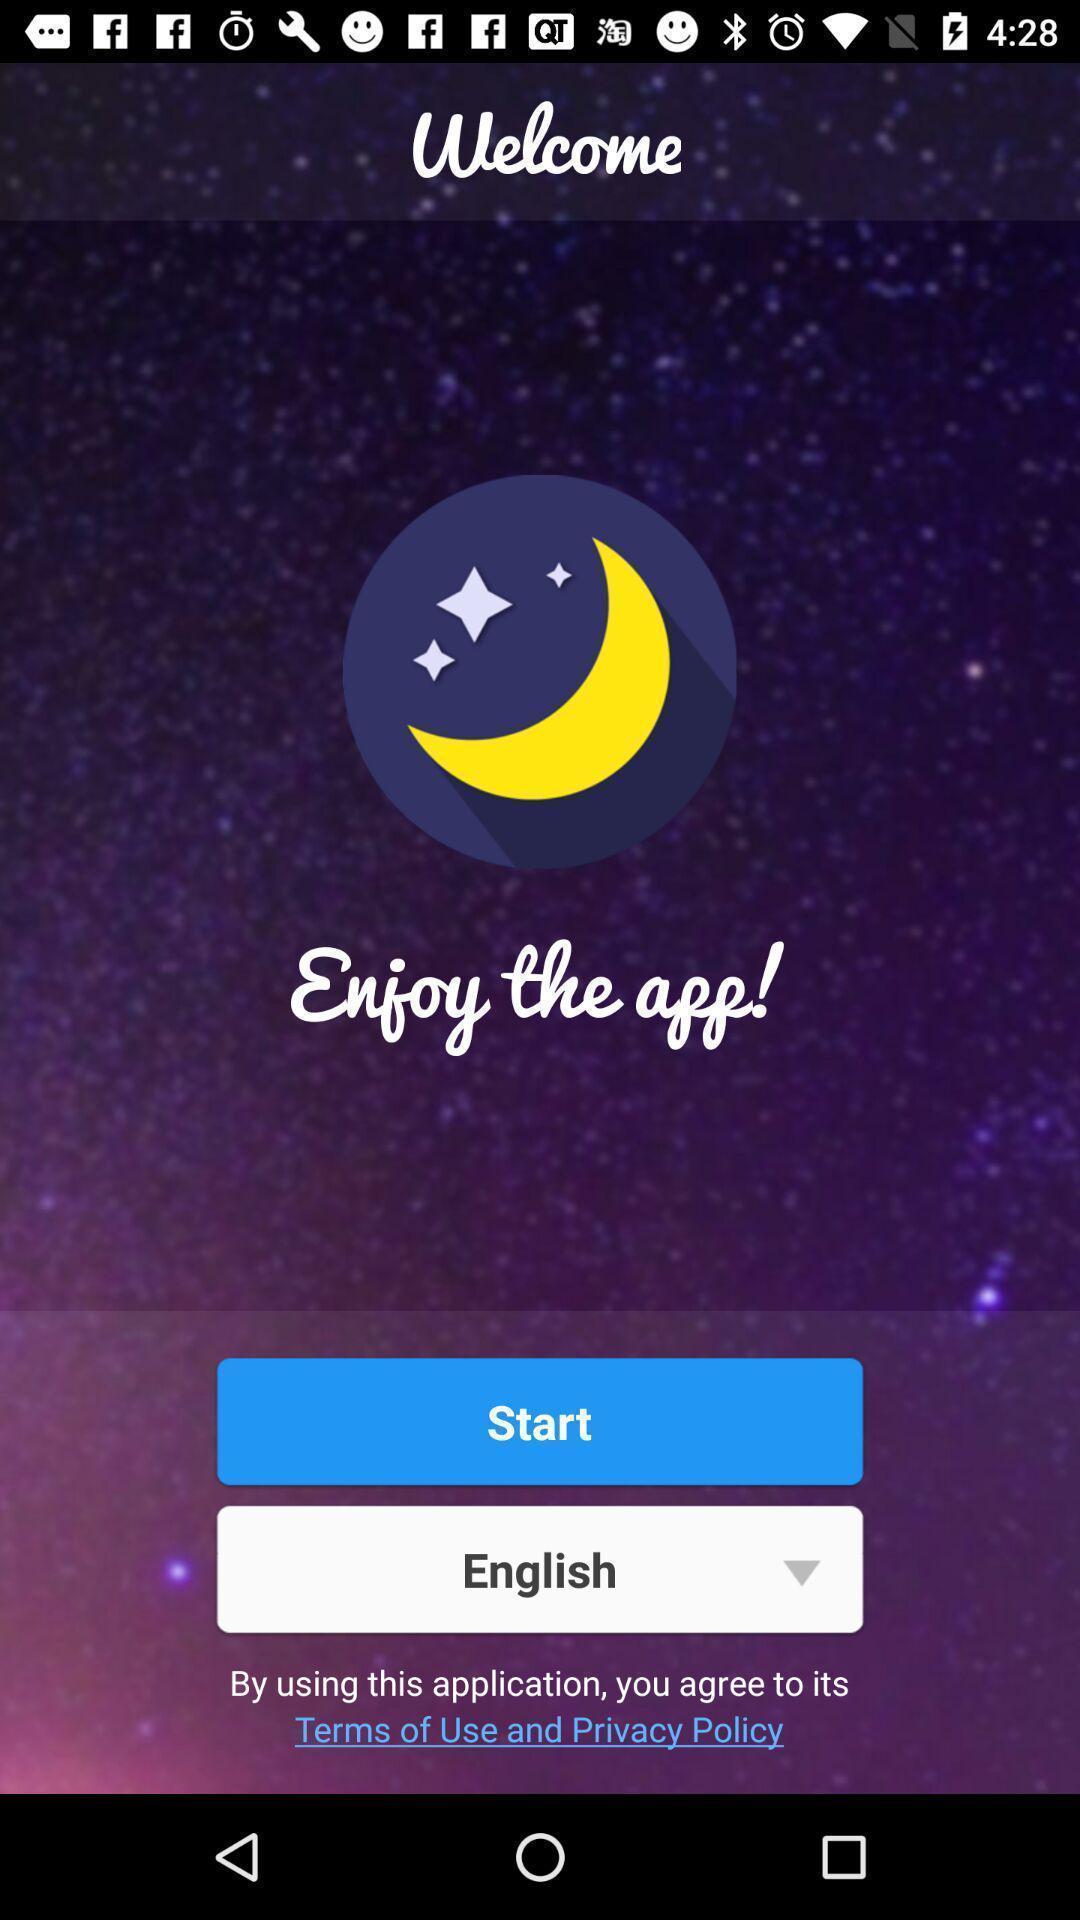Summarize the main components in this picture. Welcome page or start page. 